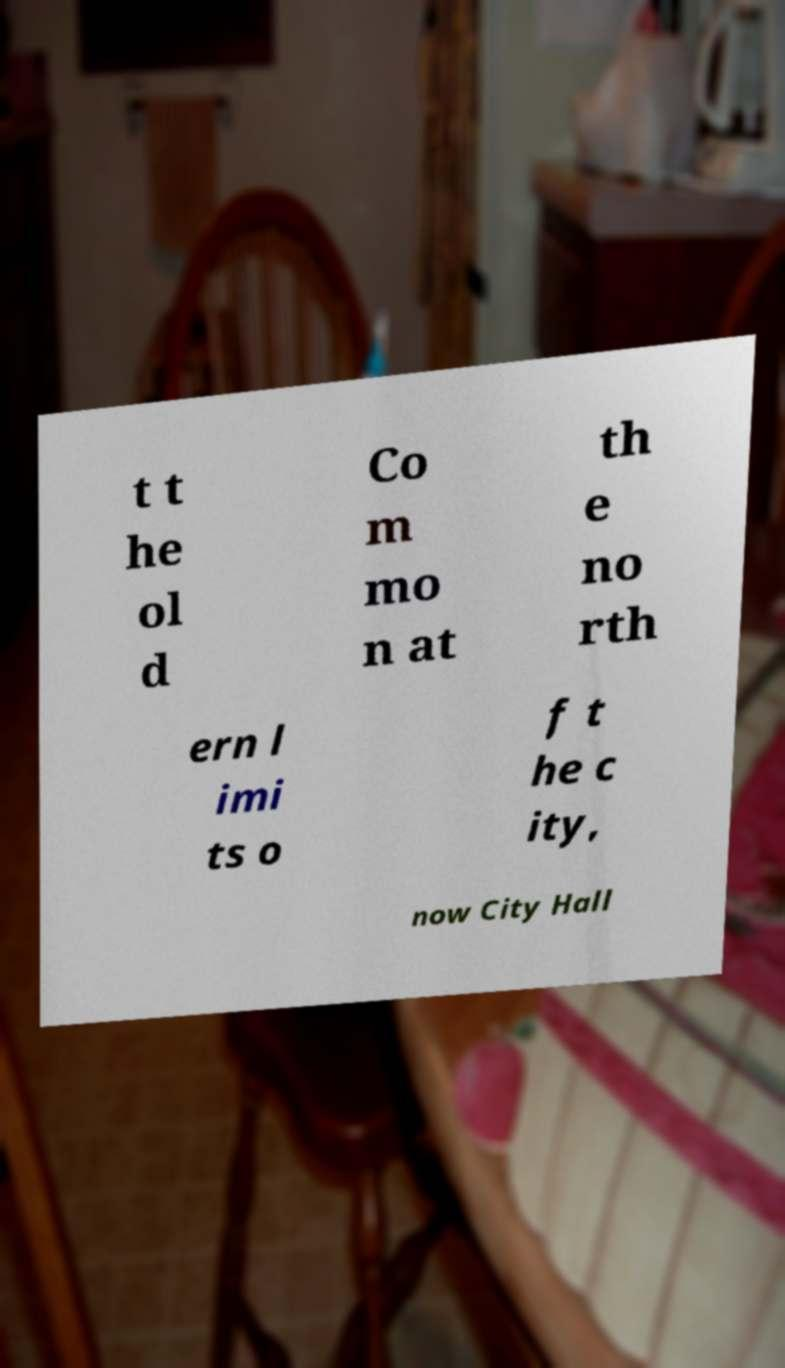Can you accurately transcribe the text from the provided image for me? t t he ol d Co m mo n at th e no rth ern l imi ts o f t he c ity, now City Hall 